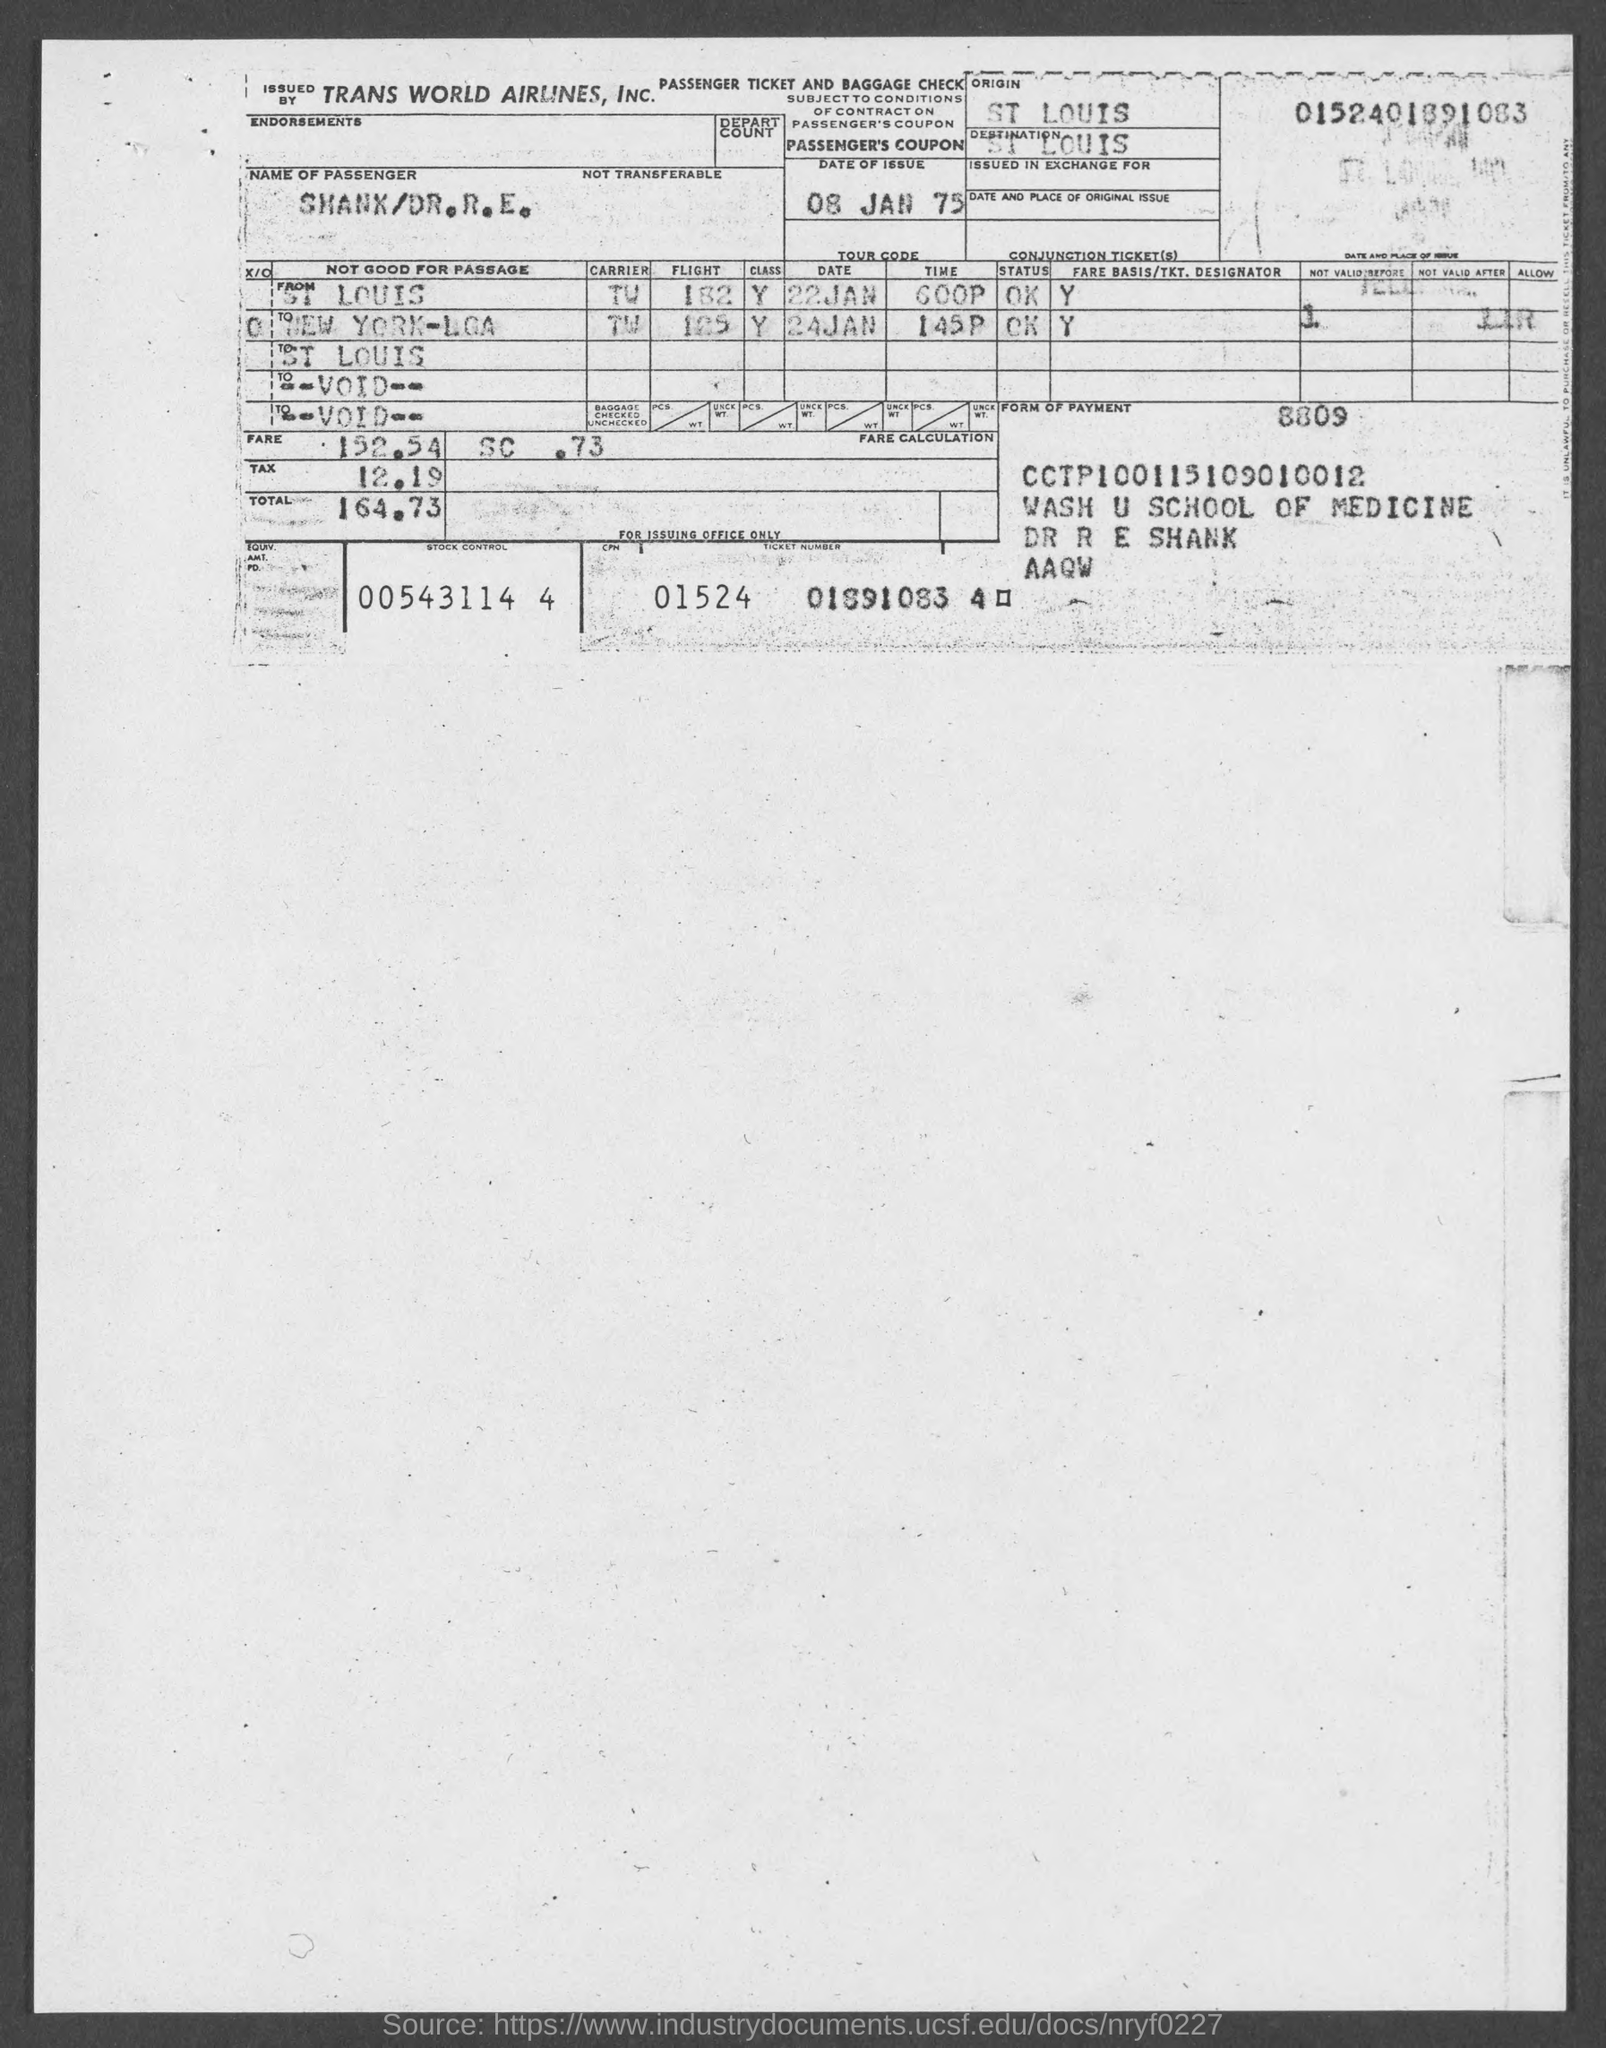What is the date of issue mentioned in the given page ?
Keep it short and to the point. 08 JAN 75. What is the origin mentioned in the given form ?
Offer a very short reply. ST LOUIS. What is the destination mentioned in the given form ?
Provide a succinct answer. ST LOUIS. What is the amount of fare mentioned in the given form ?
Your answer should be compact. 152.54. What is the amount of tax mentioned in the given form ?
Offer a very short reply. 12.19. What is the total amount mentioned in the given form ?
Your answer should be very brief. 164.73. What is the stock control number mentioned in the given page ?
Your response must be concise. 00543114 4. 